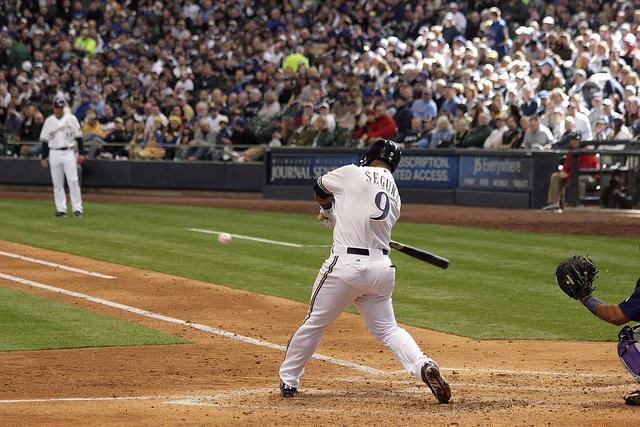How many people can you see?
Give a very brief answer. 3. 